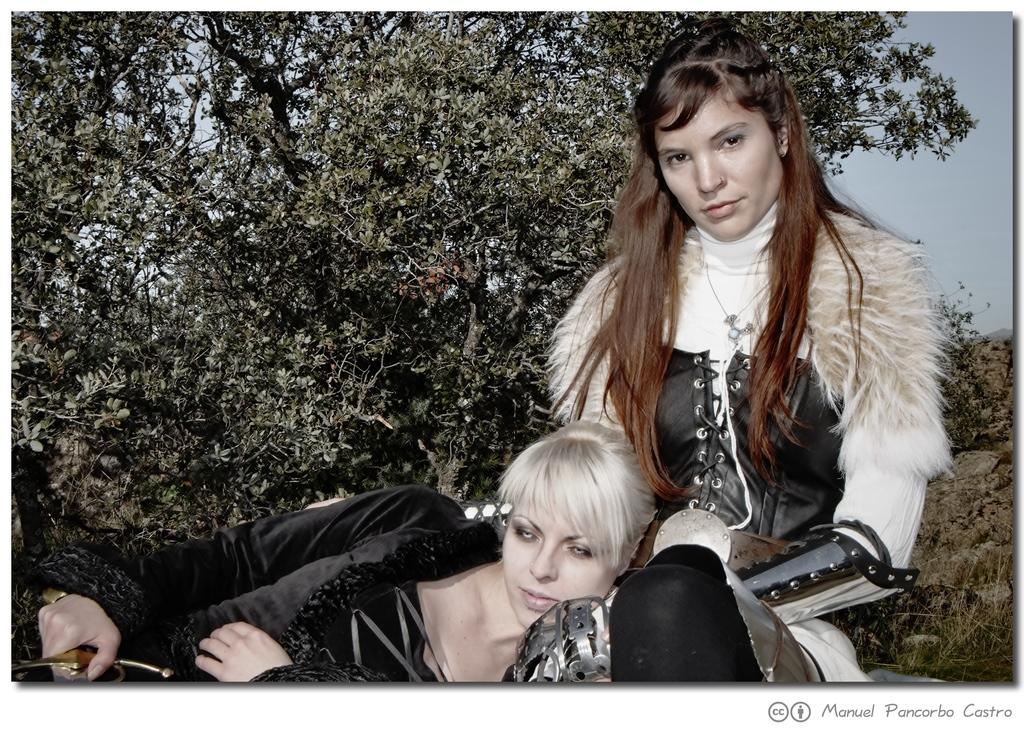How many women are in the image? There are two women in the image. What are the women wearing? The women are wearing clothes. What type of natural environment is visible in the image? There is grass and a tree visible in the image. What is the color of the sky in the image? The sky is pale blue in color. What object can be seen in the image that is typically associated with combat or warfare? There is a sword in the image. What type of operation is being performed on the tree in the image? There is no operation being performed on the tree in the image; it is a natural tree in its original state. Can you tell me where the spade is located in the image? There is no spade present in the image. 